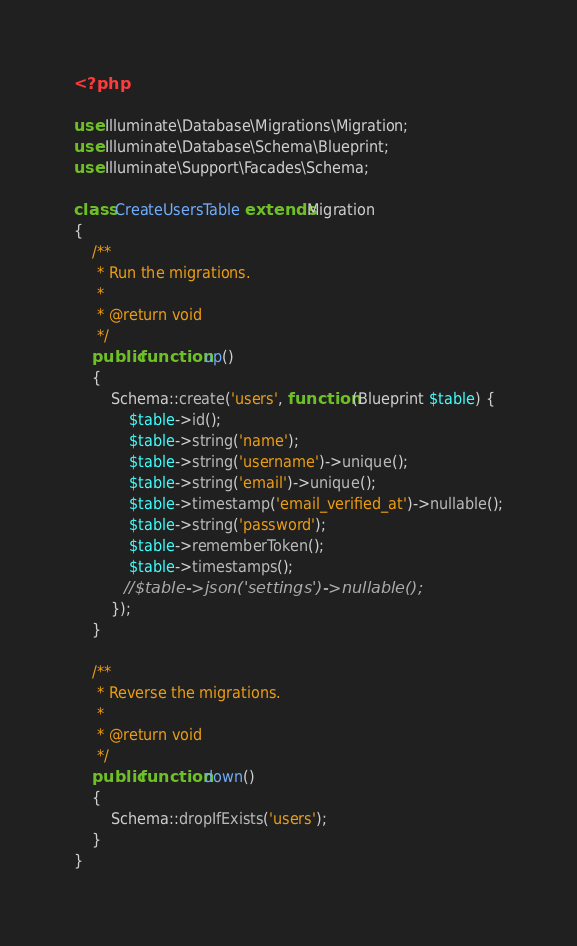<code> <loc_0><loc_0><loc_500><loc_500><_PHP_><?php

use Illuminate\Database\Migrations\Migration;
use Illuminate\Database\Schema\Blueprint;
use Illuminate\Support\Facades\Schema;

class CreateUsersTable extends Migration
{
    /**
     * Run the migrations.
     *
     * @return void
     */
    public function up()
    {
        Schema::create('users', function (Blueprint $table) {
            $table->id();
            $table->string('name');
            $table->string('username')->unique();
            $table->string('email')->unique();
            $table->timestamp('email_verified_at')->nullable();
            $table->string('password');
            $table->rememberToken();
            $table->timestamps();
           //$table->json('settings')->nullable();
        });
    }

    /**
     * Reverse the migrations.
     *
     * @return void
     */
    public function down()
    {
        Schema::dropIfExists('users');
    }
}
</code> 